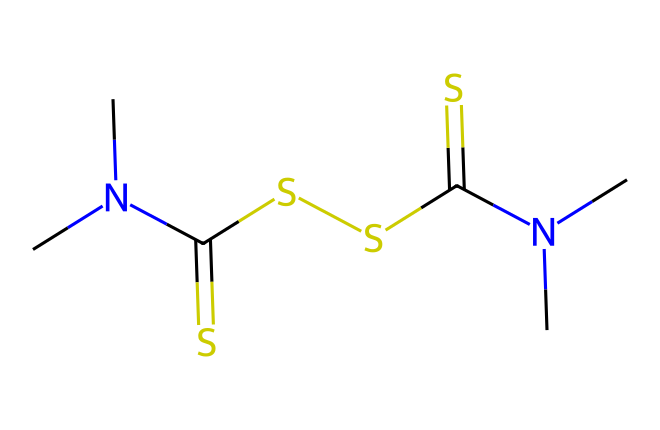What is the total number of carbon atoms in this structure? The SMILES representation indicates the presence of six carbon atoms (C) in total. Each 'C' in the SMILES corresponds to a carbon atom.
Answer: six How many sulfur atoms are present in the structure? The SMILES representation includes four sulfur atoms (S). Each 'S' represents a sulfur atom within the structure.
Answer: four What type of functional groups are present in thiram? Analyzing the structure, thiram contains thiourea (due to the presence of the C(=S) and N groups), which is indicative of its fungicidal properties.
Answer: thiourea How many nitrogen atoms can be found in thiram? The SMILES includes four nitrogen atoms (N). Each 'N' in the structure represents a nitrogen atom contributing to the overall composition of thiram.
Answer: four What is the molecular formula for the represented chemical structure? By counting the atoms in the SMILES representation, the molecular formula can be derived as C6H12N4S4, which includes six carbons, twelve hydrogens, four nitrogens, and four sulfurs.
Answer: C6H12N4S4 How does thiram primarily function as a fungicide? thiram functions as a fungicide by inhibiting the growth of fungal pathogens, primarily through its interaction with thiol groups in enzymes critical for fungal metabolism, thereby disrupting their function.
Answer: inhibiting fungal growth 